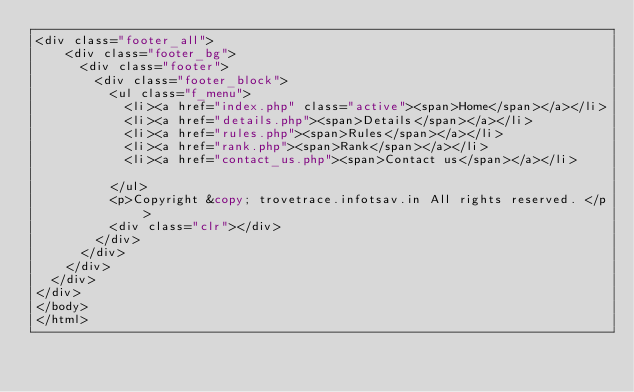<code> <loc_0><loc_0><loc_500><loc_500><_PHP_><div class="footer_all">
    <div class="footer_bg">
      <div class="footer">
        <div class="footer_block">
          <ul class="f_menu">
            <li><a href="index.php" class="active"><span>Home</span></a></li>
            <li><a href="details.php"><span>Details</span></a></li>
            <li><a href="rules.php"><span>Rules</span></a></li>
            <li><a href="rank.php"><span>Rank</span></a></li>
            <li><a href="contact_us.php"><span>Contact us</span></a></li>
            
          </ul>
          <p>Copyright &copy; trovetrace.infotsav.in All rights reserved. </p>
          <div class="clr"></div>
        </div>
      </div>
    </div>
  </div>
</div>
</body>
</html>
</code> 